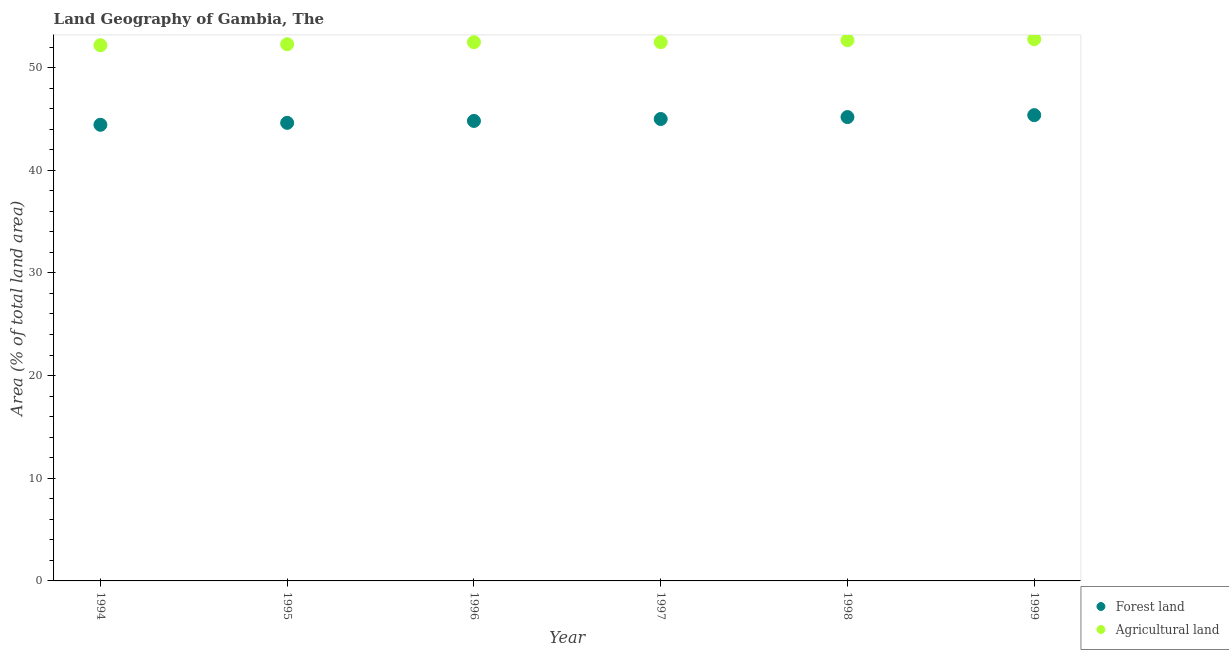Is the number of dotlines equal to the number of legend labels?
Offer a very short reply. Yes. What is the percentage of land area under agriculture in 1995?
Make the answer very short. 52.27. Across all years, what is the maximum percentage of land area under forests?
Ensure brevity in your answer.  45.37. Across all years, what is the minimum percentage of land area under agriculture?
Ensure brevity in your answer.  52.17. In which year was the percentage of land area under forests minimum?
Provide a short and direct response. 1994. What is the total percentage of land area under forests in the graph?
Provide a short and direct response. 269.38. What is the difference between the percentage of land area under forests in 1995 and that in 1998?
Give a very brief answer. -0.56. What is the difference between the percentage of land area under agriculture in 1994 and the percentage of land area under forests in 1998?
Your response must be concise. 7. What is the average percentage of land area under agriculture per year?
Provide a short and direct response. 52.47. In the year 1995, what is the difference between the percentage of land area under agriculture and percentage of land area under forests?
Give a very brief answer. 7.66. What is the ratio of the percentage of land area under forests in 1995 to that in 1996?
Your answer should be compact. 1. What is the difference between the highest and the second highest percentage of land area under agriculture?
Give a very brief answer. 0.1. What is the difference between the highest and the lowest percentage of land area under forests?
Offer a very short reply. 0.94. Is the sum of the percentage of land area under forests in 1994 and 1997 greater than the maximum percentage of land area under agriculture across all years?
Your response must be concise. Yes. Is the percentage of land area under agriculture strictly greater than the percentage of land area under forests over the years?
Make the answer very short. Yes. Is the percentage of land area under forests strictly less than the percentage of land area under agriculture over the years?
Keep it short and to the point. Yes. How many dotlines are there?
Your answer should be compact. 2. How many years are there in the graph?
Provide a short and direct response. 6. What is the difference between two consecutive major ticks on the Y-axis?
Ensure brevity in your answer.  10. Are the values on the major ticks of Y-axis written in scientific E-notation?
Give a very brief answer. No. Does the graph contain grids?
Your answer should be very brief. No. How many legend labels are there?
Keep it short and to the point. 2. What is the title of the graph?
Ensure brevity in your answer.  Land Geography of Gambia, The. Does "Non-pregnant women" appear as one of the legend labels in the graph?
Keep it short and to the point. No. What is the label or title of the Y-axis?
Provide a succinct answer. Area (% of total land area). What is the Area (% of total land area) of Forest land in 1994?
Your answer should be very brief. 44.43. What is the Area (% of total land area) in Agricultural land in 1994?
Ensure brevity in your answer.  52.17. What is the Area (% of total land area) of Forest land in 1995?
Your answer should be compact. 44.61. What is the Area (% of total land area) in Agricultural land in 1995?
Keep it short and to the point. 52.27. What is the Area (% of total land area) in Forest land in 1996?
Offer a terse response. 44.8. What is the Area (% of total land area) in Agricultural land in 1996?
Make the answer very short. 52.47. What is the Area (% of total land area) in Forest land in 1997?
Ensure brevity in your answer.  44.99. What is the Area (% of total land area) in Agricultural land in 1997?
Offer a terse response. 52.47. What is the Area (% of total land area) of Forest land in 1998?
Make the answer very short. 45.18. What is the Area (% of total land area) in Agricultural land in 1998?
Offer a very short reply. 52.67. What is the Area (% of total land area) of Forest land in 1999?
Your answer should be compact. 45.37. What is the Area (% of total land area) of Agricultural land in 1999?
Your response must be concise. 52.77. Across all years, what is the maximum Area (% of total land area) in Forest land?
Make the answer very short. 45.37. Across all years, what is the maximum Area (% of total land area) in Agricultural land?
Your answer should be compact. 52.77. Across all years, what is the minimum Area (% of total land area) of Forest land?
Make the answer very short. 44.43. Across all years, what is the minimum Area (% of total land area) in Agricultural land?
Provide a short and direct response. 52.17. What is the total Area (% of total land area) of Forest land in the graph?
Offer a very short reply. 269.38. What is the total Area (% of total land area) in Agricultural land in the graph?
Ensure brevity in your answer.  314.82. What is the difference between the Area (% of total land area) of Forest land in 1994 and that in 1995?
Keep it short and to the point. -0.19. What is the difference between the Area (% of total land area) in Agricultural land in 1994 and that in 1995?
Keep it short and to the point. -0.1. What is the difference between the Area (% of total land area) of Forest land in 1994 and that in 1996?
Give a very brief answer. -0.38. What is the difference between the Area (% of total land area) in Agricultural land in 1994 and that in 1996?
Ensure brevity in your answer.  -0.3. What is the difference between the Area (% of total land area) in Forest land in 1994 and that in 1997?
Your answer should be compact. -0.56. What is the difference between the Area (% of total land area) of Agricultural land in 1994 and that in 1997?
Make the answer very short. -0.3. What is the difference between the Area (% of total land area) in Forest land in 1994 and that in 1998?
Offer a very short reply. -0.75. What is the difference between the Area (% of total land area) in Agricultural land in 1994 and that in 1998?
Offer a terse response. -0.49. What is the difference between the Area (% of total land area) of Forest land in 1994 and that in 1999?
Your answer should be compact. -0.94. What is the difference between the Area (% of total land area) of Agricultural land in 1994 and that in 1999?
Your answer should be compact. -0.59. What is the difference between the Area (% of total land area) in Forest land in 1995 and that in 1996?
Offer a very short reply. -0.19. What is the difference between the Area (% of total land area) of Agricultural land in 1995 and that in 1996?
Make the answer very short. -0.2. What is the difference between the Area (% of total land area) of Forest land in 1995 and that in 1997?
Give a very brief answer. -0.38. What is the difference between the Area (% of total land area) of Agricultural land in 1995 and that in 1997?
Your answer should be very brief. -0.2. What is the difference between the Area (% of total land area) in Forest land in 1995 and that in 1998?
Ensure brevity in your answer.  -0.56. What is the difference between the Area (% of total land area) of Agricultural land in 1995 and that in 1998?
Make the answer very short. -0.4. What is the difference between the Area (% of total land area) of Forest land in 1995 and that in 1999?
Offer a very short reply. -0.75. What is the difference between the Area (% of total land area) of Agricultural land in 1995 and that in 1999?
Ensure brevity in your answer.  -0.49. What is the difference between the Area (% of total land area) of Forest land in 1996 and that in 1997?
Provide a short and direct response. -0.19. What is the difference between the Area (% of total land area) of Forest land in 1996 and that in 1998?
Provide a succinct answer. -0.38. What is the difference between the Area (% of total land area) in Agricultural land in 1996 and that in 1998?
Provide a succinct answer. -0.2. What is the difference between the Area (% of total land area) in Forest land in 1996 and that in 1999?
Your response must be concise. -0.56. What is the difference between the Area (% of total land area) of Agricultural land in 1996 and that in 1999?
Make the answer very short. -0.3. What is the difference between the Area (% of total land area) of Forest land in 1997 and that in 1998?
Give a very brief answer. -0.19. What is the difference between the Area (% of total land area) in Agricultural land in 1997 and that in 1998?
Your answer should be compact. -0.2. What is the difference between the Area (% of total land area) in Forest land in 1997 and that in 1999?
Your response must be concise. -0.38. What is the difference between the Area (% of total land area) in Agricultural land in 1997 and that in 1999?
Give a very brief answer. -0.3. What is the difference between the Area (% of total land area) of Forest land in 1998 and that in 1999?
Keep it short and to the point. -0.19. What is the difference between the Area (% of total land area) in Agricultural land in 1998 and that in 1999?
Your answer should be compact. -0.1. What is the difference between the Area (% of total land area) in Forest land in 1994 and the Area (% of total land area) in Agricultural land in 1995?
Make the answer very short. -7.85. What is the difference between the Area (% of total land area) of Forest land in 1994 and the Area (% of total land area) of Agricultural land in 1996?
Your answer should be compact. -8.04. What is the difference between the Area (% of total land area) in Forest land in 1994 and the Area (% of total land area) in Agricultural land in 1997?
Keep it short and to the point. -8.04. What is the difference between the Area (% of total land area) in Forest land in 1994 and the Area (% of total land area) in Agricultural land in 1998?
Ensure brevity in your answer.  -8.24. What is the difference between the Area (% of total land area) in Forest land in 1994 and the Area (% of total land area) in Agricultural land in 1999?
Keep it short and to the point. -8.34. What is the difference between the Area (% of total land area) of Forest land in 1995 and the Area (% of total land area) of Agricultural land in 1996?
Your answer should be very brief. -7.86. What is the difference between the Area (% of total land area) of Forest land in 1995 and the Area (% of total land area) of Agricultural land in 1997?
Provide a short and direct response. -7.86. What is the difference between the Area (% of total land area) in Forest land in 1995 and the Area (% of total land area) in Agricultural land in 1998?
Your answer should be very brief. -8.05. What is the difference between the Area (% of total land area) in Forest land in 1995 and the Area (% of total land area) in Agricultural land in 1999?
Provide a succinct answer. -8.15. What is the difference between the Area (% of total land area) of Forest land in 1996 and the Area (% of total land area) of Agricultural land in 1997?
Provide a short and direct response. -7.67. What is the difference between the Area (% of total land area) in Forest land in 1996 and the Area (% of total land area) in Agricultural land in 1998?
Your answer should be very brief. -7.87. What is the difference between the Area (% of total land area) of Forest land in 1996 and the Area (% of total land area) of Agricultural land in 1999?
Give a very brief answer. -7.96. What is the difference between the Area (% of total land area) of Forest land in 1997 and the Area (% of total land area) of Agricultural land in 1998?
Your response must be concise. -7.68. What is the difference between the Area (% of total land area) of Forest land in 1997 and the Area (% of total land area) of Agricultural land in 1999?
Keep it short and to the point. -7.78. What is the difference between the Area (% of total land area) of Forest land in 1998 and the Area (% of total land area) of Agricultural land in 1999?
Offer a very short reply. -7.59. What is the average Area (% of total land area) in Forest land per year?
Your answer should be very brief. 44.9. What is the average Area (% of total land area) of Agricultural land per year?
Keep it short and to the point. 52.47. In the year 1994, what is the difference between the Area (% of total land area) in Forest land and Area (% of total land area) in Agricultural land?
Keep it short and to the point. -7.75. In the year 1995, what is the difference between the Area (% of total land area) of Forest land and Area (% of total land area) of Agricultural land?
Offer a very short reply. -7.66. In the year 1996, what is the difference between the Area (% of total land area) in Forest land and Area (% of total land area) in Agricultural land?
Ensure brevity in your answer.  -7.67. In the year 1997, what is the difference between the Area (% of total land area) of Forest land and Area (% of total land area) of Agricultural land?
Provide a succinct answer. -7.48. In the year 1998, what is the difference between the Area (% of total land area) of Forest land and Area (% of total land area) of Agricultural land?
Your response must be concise. -7.49. In the year 1999, what is the difference between the Area (% of total land area) of Forest land and Area (% of total land area) of Agricultural land?
Give a very brief answer. -7.4. What is the ratio of the Area (% of total land area) of Forest land in 1994 to that in 1996?
Provide a short and direct response. 0.99. What is the ratio of the Area (% of total land area) of Agricultural land in 1994 to that in 1996?
Make the answer very short. 0.99. What is the ratio of the Area (% of total land area) in Forest land in 1994 to that in 1997?
Provide a succinct answer. 0.99. What is the ratio of the Area (% of total land area) in Agricultural land in 1994 to that in 1997?
Ensure brevity in your answer.  0.99. What is the ratio of the Area (% of total land area) in Forest land in 1994 to that in 1998?
Your response must be concise. 0.98. What is the ratio of the Area (% of total land area) in Agricultural land in 1994 to that in 1998?
Offer a very short reply. 0.99. What is the ratio of the Area (% of total land area) of Forest land in 1994 to that in 1999?
Provide a succinct answer. 0.98. What is the ratio of the Area (% of total land area) of Agricultural land in 1994 to that in 1999?
Offer a very short reply. 0.99. What is the ratio of the Area (% of total land area) in Agricultural land in 1995 to that in 1997?
Make the answer very short. 1. What is the ratio of the Area (% of total land area) of Forest land in 1995 to that in 1998?
Offer a terse response. 0.99. What is the ratio of the Area (% of total land area) of Agricultural land in 1995 to that in 1998?
Keep it short and to the point. 0.99. What is the ratio of the Area (% of total land area) in Forest land in 1995 to that in 1999?
Offer a terse response. 0.98. What is the ratio of the Area (% of total land area) in Agricultural land in 1995 to that in 1999?
Provide a short and direct response. 0.99. What is the ratio of the Area (% of total land area) in Forest land in 1996 to that in 1997?
Make the answer very short. 1. What is the ratio of the Area (% of total land area) of Agricultural land in 1996 to that in 1997?
Your answer should be very brief. 1. What is the ratio of the Area (% of total land area) of Forest land in 1996 to that in 1998?
Give a very brief answer. 0.99. What is the ratio of the Area (% of total land area) in Agricultural land in 1996 to that in 1998?
Make the answer very short. 1. What is the ratio of the Area (% of total land area) of Forest land in 1996 to that in 1999?
Keep it short and to the point. 0.99. What is the ratio of the Area (% of total land area) of Forest land in 1997 to that in 1999?
Your response must be concise. 0.99. What is the difference between the highest and the second highest Area (% of total land area) of Forest land?
Offer a terse response. 0.19. What is the difference between the highest and the second highest Area (% of total land area) in Agricultural land?
Offer a terse response. 0.1. What is the difference between the highest and the lowest Area (% of total land area) in Forest land?
Ensure brevity in your answer.  0.94. What is the difference between the highest and the lowest Area (% of total land area) of Agricultural land?
Your answer should be very brief. 0.59. 